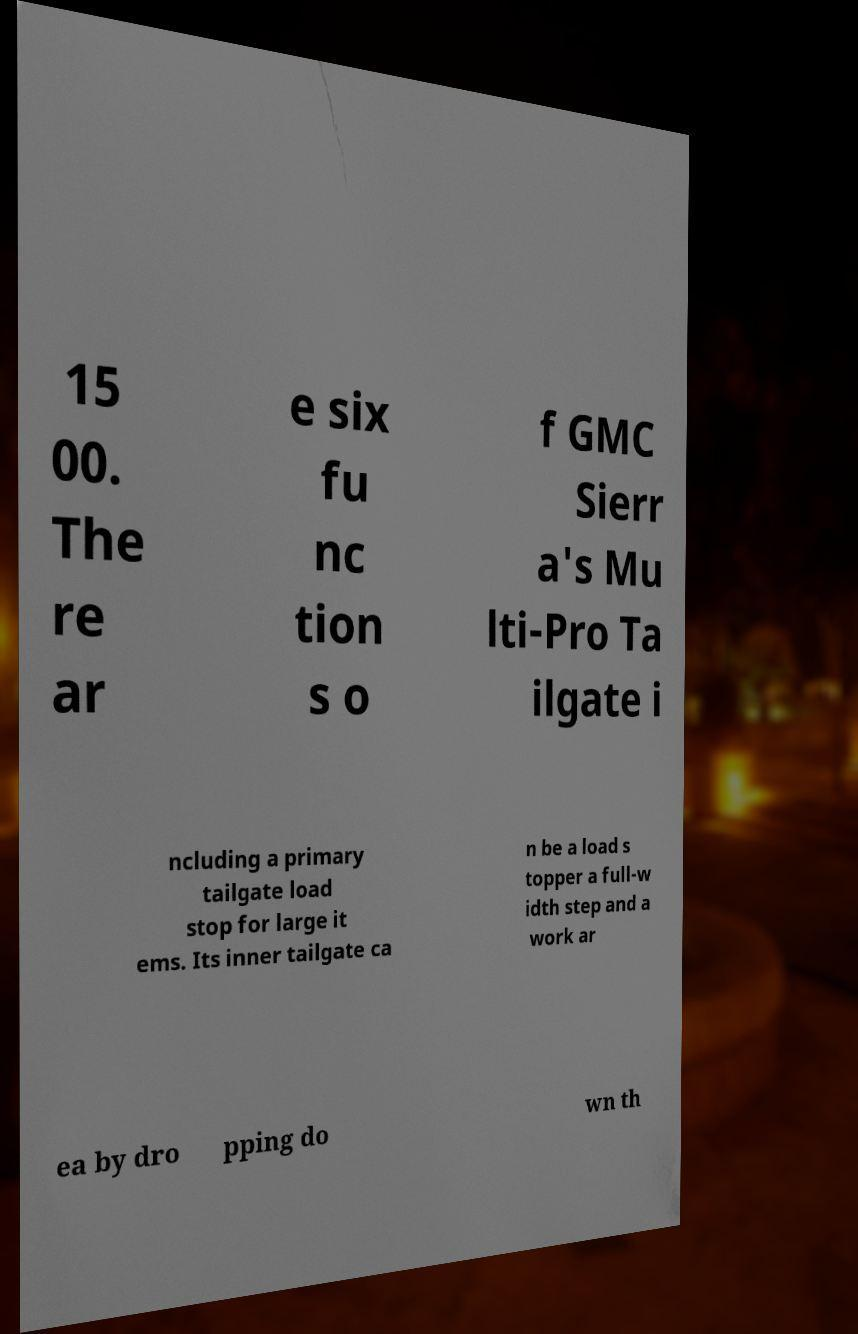Please read and relay the text visible in this image. What does it say? 15 00. The re ar e six fu nc tion s o f GMC Sierr a's Mu lti-Pro Ta ilgate i ncluding a primary tailgate load stop for large it ems. Its inner tailgate ca n be a load s topper a full-w idth step and a work ar ea by dro pping do wn th 